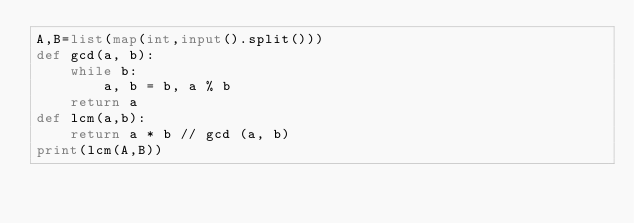Convert code to text. <code><loc_0><loc_0><loc_500><loc_500><_Python_>A,B=list(map(int,input().split()))
def gcd(a, b):
    while b:
        a, b = b, a % b
    return a
def lcm(a,b):
    return a * b // gcd (a, b)
print(lcm(A,B))</code> 